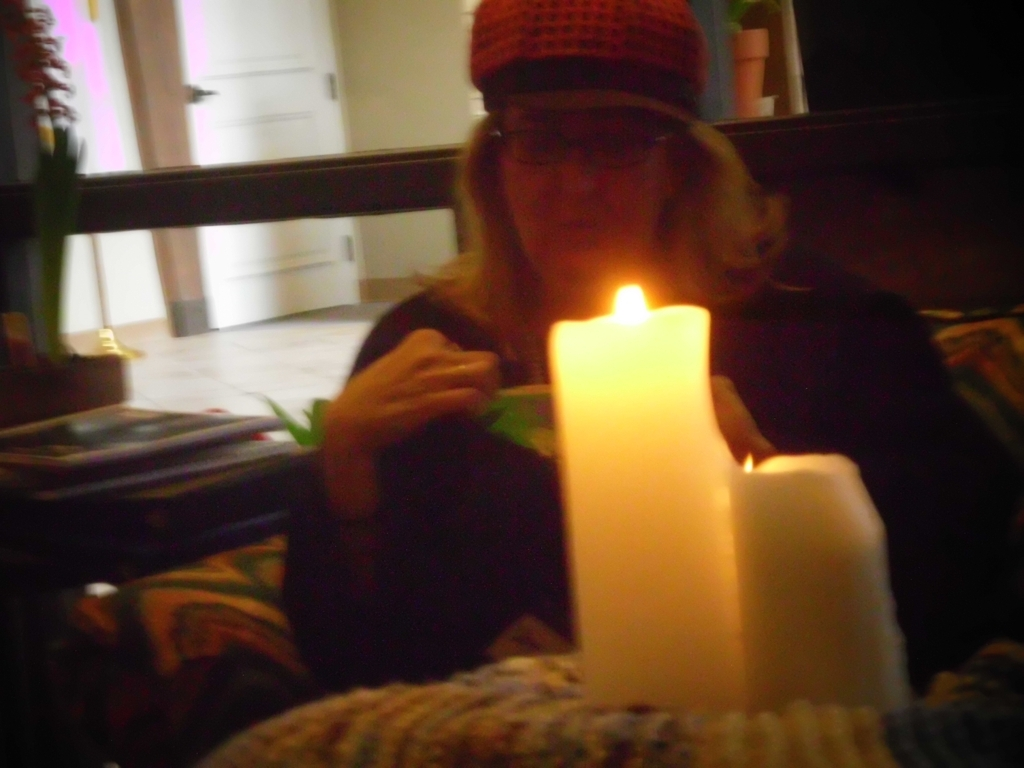How is the lighting in this image?
A. Sufficient
B. Dim
C. Average
D. Bright The lighting in the photograph appears somewhat dim, primarily provided by the warm glow of the candle in the foreground, casting a soft, amber light that creates deep shadows and doesn't fully illuminate the person or the background objects. Although there is some light that seems to come from the outside, given the window in the background, it does not significantly contribute to the overall brightness. Therefore, the most accurate description of the lighting condition is option B, Dim; however, the glowing candle adds a cozy and serene atmosphere to the scene. 